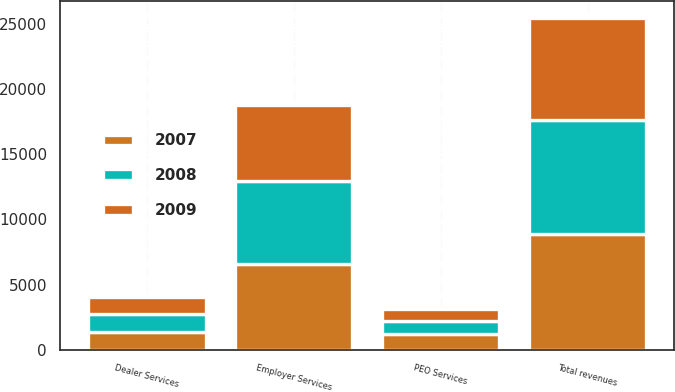Convert chart to OTSL. <chart><loc_0><loc_0><loc_500><loc_500><stacked_bar_chart><ecel><fcel>Employer Services<fcel>PEO Services<fcel>Dealer Services<fcel>Total revenues<nl><fcel>2007<fcel>6587.7<fcel>1185.8<fcel>1348.6<fcel>8867.1<nl><fcel>2008<fcel>6362.4<fcel>1060.5<fcel>1391.4<fcel>8776.5<nl><fcel>2009<fcel>5816.3<fcel>884.8<fcel>1280.6<fcel>7800<nl></chart> 